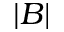Convert formula to latex. <formula><loc_0><loc_0><loc_500><loc_500>| B |</formula> 